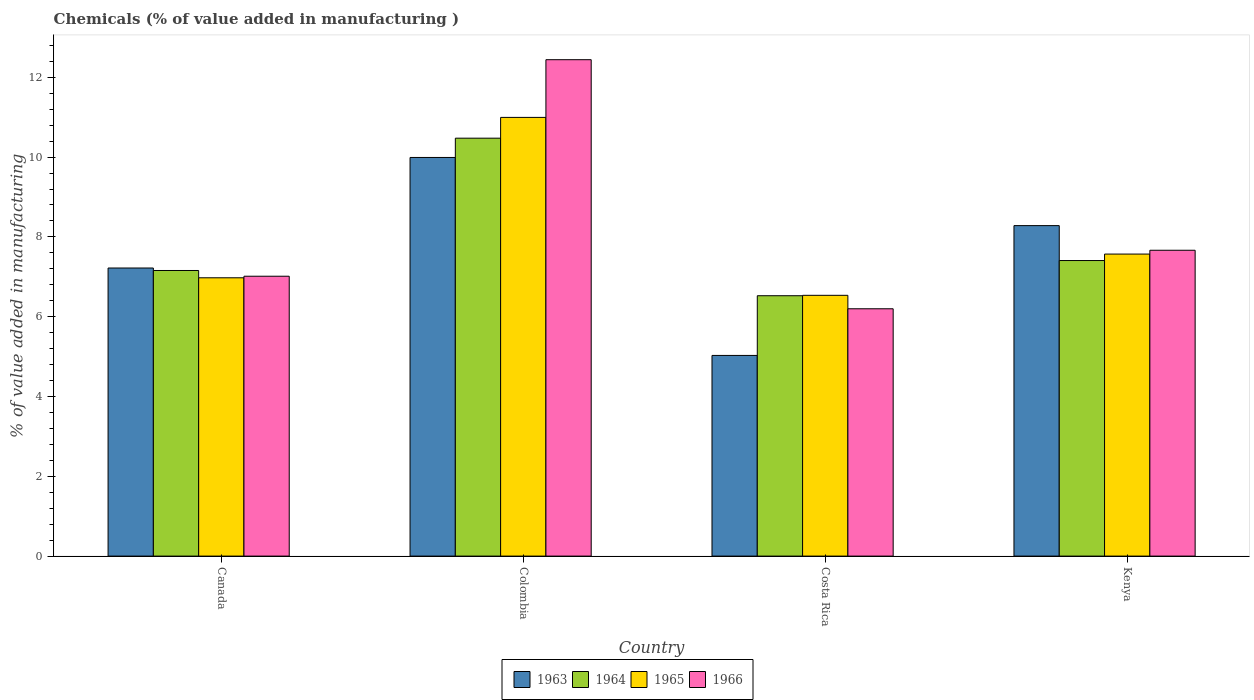How many different coloured bars are there?
Keep it short and to the point. 4. Are the number of bars per tick equal to the number of legend labels?
Offer a terse response. Yes. How many bars are there on the 1st tick from the right?
Your response must be concise. 4. In how many cases, is the number of bars for a given country not equal to the number of legend labels?
Provide a succinct answer. 0. What is the value added in manufacturing chemicals in 1965 in Kenya?
Offer a very short reply. 7.57. Across all countries, what is the maximum value added in manufacturing chemicals in 1963?
Provide a short and direct response. 9.99. Across all countries, what is the minimum value added in manufacturing chemicals in 1964?
Make the answer very short. 6.53. What is the total value added in manufacturing chemicals in 1965 in the graph?
Give a very brief answer. 32.08. What is the difference between the value added in manufacturing chemicals in 1963 in Colombia and that in Kenya?
Your answer should be very brief. 1.71. What is the difference between the value added in manufacturing chemicals in 1965 in Kenya and the value added in manufacturing chemicals in 1966 in Colombia?
Ensure brevity in your answer.  -4.87. What is the average value added in manufacturing chemicals in 1965 per country?
Your response must be concise. 8.02. What is the difference between the value added in manufacturing chemicals of/in 1964 and value added in manufacturing chemicals of/in 1965 in Canada?
Offer a terse response. 0.18. What is the ratio of the value added in manufacturing chemicals in 1965 in Canada to that in Costa Rica?
Offer a very short reply. 1.07. Is the value added in manufacturing chemicals in 1963 in Colombia less than that in Kenya?
Give a very brief answer. No. What is the difference between the highest and the second highest value added in manufacturing chemicals in 1964?
Your response must be concise. 3.32. What is the difference between the highest and the lowest value added in manufacturing chemicals in 1963?
Offer a very short reply. 4.96. Is the sum of the value added in manufacturing chemicals in 1966 in Canada and Kenya greater than the maximum value added in manufacturing chemicals in 1963 across all countries?
Keep it short and to the point. Yes. What does the 3rd bar from the left in Costa Rica represents?
Your answer should be compact. 1965. What does the 1st bar from the right in Colombia represents?
Your answer should be very brief. 1966. Is it the case that in every country, the sum of the value added in manufacturing chemicals in 1963 and value added in manufacturing chemicals in 1964 is greater than the value added in manufacturing chemicals in 1966?
Offer a terse response. Yes. How many countries are there in the graph?
Keep it short and to the point. 4. What is the difference between two consecutive major ticks on the Y-axis?
Give a very brief answer. 2. Does the graph contain any zero values?
Your response must be concise. No. How many legend labels are there?
Offer a terse response. 4. What is the title of the graph?
Provide a succinct answer. Chemicals (% of value added in manufacturing ). Does "1993" appear as one of the legend labels in the graph?
Your response must be concise. No. What is the label or title of the Y-axis?
Offer a terse response. % of value added in manufacturing. What is the % of value added in manufacturing of 1963 in Canada?
Give a very brief answer. 7.22. What is the % of value added in manufacturing of 1964 in Canada?
Offer a terse response. 7.16. What is the % of value added in manufacturing of 1965 in Canada?
Your answer should be very brief. 6.98. What is the % of value added in manufacturing in 1966 in Canada?
Your response must be concise. 7.01. What is the % of value added in manufacturing in 1963 in Colombia?
Offer a terse response. 9.99. What is the % of value added in manufacturing in 1964 in Colombia?
Give a very brief answer. 10.47. What is the % of value added in manufacturing in 1965 in Colombia?
Offer a terse response. 10.99. What is the % of value added in manufacturing of 1966 in Colombia?
Your answer should be compact. 12.44. What is the % of value added in manufacturing in 1963 in Costa Rica?
Your response must be concise. 5.03. What is the % of value added in manufacturing in 1964 in Costa Rica?
Provide a short and direct response. 6.53. What is the % of value added in manufacturing in 1965 in Costa Rica?
Provide a succinct answer. 6.54. What is the % of value added in manufacturing of 1966 in Costa Rica?
Offer a very short reply. 6.2. What is the % of value added in manufacturing of 1963 in Kenya?
Give a very brief answer. 8.28. What is the % of value added in manufacturing in 1964 in Kenya?
Your answer should be compact. 7.41. What is the % of value added in manufacturing of 1965 in Kenya?
Make the answer very short. 7.57. What is the % of value added in manufacturing in 1966 in Kenya?
Give a very brief answer. 7.67. Across all countries, what is the maximum % of value added in manufacturing of 1963?
Make the answer very short. 9.99. Across all countries, what is the maximum % of value added in manufacturing of 1964?
Offer a terse response. 10.47. Across all countries, what is the maximum % of value added in manufacturing of 1965?
Ensure brevity in your answer.  10.99. Across all countries, what is the maximum % of value added in manufacturing in 1966?
Provide a succinct answer. 12.44. Across all countries, what is the minimum % of value added in manufacturing of 1963?
Provide a short and direct response. 5.03. Across all countries, what is the minimum % of value added in manufacturing of 1964?
Your answer should be compact. 6.53. Across all countries, what is the minimum % of value added in manufacturing in 1965?
Offer a very short reply. 6.54. Across all countries, what is the minimum % of value added in manufacturing of 1966?
Your answer should be very brief. 6.2. What is the total % of value added in manufacturing of 1963 in the graph?
Your response must be concise. 30.52. What is the total % of value added in manufacturing of 1964 in the graph?
Give a very brief answer. 31.57. What is the total % of value added in manufacturing of 1965 in the graph?
Keep it short and to the point. 32.08. What is the total % of value added in manufacturing in 1966 in the graph?
Provide a succinct answer. 33.32. What is the difference between the % of value added in manufacturing in 1963 in Canada and that in Colombia?
Provide a short and direct response. -2.77. What is the difference between the % of value added in manufacturing of 1964 in Canada and that in Colombia?
Make the answer very short. -3.32. What is the difference between the % of value added in manufacturing in 1965 in Canada and that in Colombia?
Keep it short and to the point. -4.02. What is the difference between the % of value added in manufacturing in 1966 in Canada and that in Colombia?
Give a very brief answer. -5.43. What is the difference between the % of value added in manufacturing in 1963 in Canada and that in Costa Rica?
Keep it short and to the point. 2.19. What is the difference between the % of value added in manufacturing in 1964 in Canada and that in Costa Rica?
Your response must be concise. 0.63. What is the difference between the % of value added in manufacturing in 1965 in Canada and that in Costa Rica?
Make the answer very short. 0.44. What is the difference between the % of value added in manufacturing in 1966 in Canada and that in Costa Rica?
Your response must be concise. 0.82. What is the difference between the % of value added in manufacturing in 1963 in Canada and that in Kenya?
Give a very brief answer. -1.06. What is the difference between the % of value added in manufacturing in 1964 in Canada and that in Kenya?
Your response must be concise. -0.25. What is the difference between the % of value added in manufacturing in 1965 in Canada and that in Kenya?
Ensure brevity in your answer.  -0.59. What is the difference between the % of value added in manufacturing of 1966 in Canada and that in Kenya?
Provide a succinct answer. -0.65. What is the difference between the % of value added in manufacturing in 1963 in Colombia and that in Costa Rica?
Provide a short and direct response. 4.96. What is the difference between the % of value added in manufacturing in 1964 in Colombia and that in Costa Rica?
Make the answer very short. 3.95. What is the difference between the % of value added in manufacturing in 1965 in Colombia and that in Costa Rica?
Provide a short and direct response. 4.46. What is the difference between the % of value added in manufacturing of 1966 in Colombia and that in Costa Rica?
Offer a terse response. 6.24. What is the difference between the % of value added in manufacturing in 1963 in Colombia and that in Kenya?
Keep it short and to the point. 1.71. What is the difference between the % of value added in manufacturing in 1964 in Colombia and that in Kenya?
Give a very brief answer. 3.07. What is the difference between the % of value added in manufacturing of 1965 in Colombia and that in Kenya?
Keep it short and to the point. 3.43. What is the difference between the % of value added in manufacturing in 1966 in Colombia and that in Kenya?
Make the answer very short. 4.78. What is the difference between the % of value added in manufacturing of 1963 in Costa Rica and that in Kenya?
Make the answer very short. -3.25. What is the difference between the % of value added in manufacturing in 1964 in Costa Rica and that in Kenya?
Keep it short and to the point. -0.88. What is the difference between the % of value added in manufacturing in 1965 in Costa Rica and that in Kenya?
Make the answer very short. -1.03. What is the difference between the % of value added in manufacturing of 1966 in Costa Rica and that in Kenya?
Your answer should be very brief. -1.47. What is the difference between the % of value added in manufacturing in 1963 in Canada and the % of value added in manufacturing in 1964 in Colombia?
Your answer should be compact. -3.25. What is the difference between the % of value added in manufacturing in 1963 in Canada and the % of value added in manufacturing in 1965 in Colombia?
Your response must be concise. -3.77. What is the difference between the % of value added in manufacturing of 1963 in Canada and the % of value added in manufacturing of 1966 in Colombia?
Your answer should be very brief. -5.22. What is the difference between the % of value added in manufacturing in 1964 in Canada and the % of value added in manufacturing in 1965 in Colombia?
Provide a succinct answer. -3.84. What is the difference between the % of value added in manufacturing of 1964 in Canada and the % of value added in manufacturing of 1966 in Colombia?
Your answer should be compact. -5.28. What is the difference between the % of value added in manufacturing in 1965 in Canada and the % of value added in manufacturing in 1966 in Colombia?
Your response must be concise. -5.47. What is the difference between the % of value added in manufacturing of 1963 in Canada and the % of value added in manufacturing of 1964 in Costa Rica?
Provide a succinct answer. 0.69. What is the difference between the % of value added in manufacturing in 1963 in Canada and the % of value added in manufacturing in 1965 in Costa Rica?
Ensure brevity in your answer.  0.68. What is the difference between the % of value added in manufacturing of 1963 in Canada and the % of value added in manufacturing of 1966 in Costa Rica?
Offer a very short reply. 1.02. What is the difference between the % of value added in manufacturing in 1964 in Canada and the % of value added in manufacturing in 1965 in Costa Rica?
Ensure brevity in your answer.  0.62. What is the difference between the % of value added in manufacturing of 1964 in Canada and the % of value added in manufacturing of 1966 in Costa Rica?
Your response must be concise. 0.96. What is the difference between the % of value added in manufacturing in 1965 in Canada and the % of value added in manufacturing in 1966 in Costa Rica?
Keep it short and to the point. 0.78. What is the difference between the % of value added in manufacturing of 1963 in Canada and the % of value added in manufacturing of 1964 in Kenya?
Provide a short and direct response. -0.19. What is the difference between the % of value added in manufacturing of 1963 in Canada and the % of value added in manufacturing of 1965 in Kenya?
Give a very brief answer. -0.35. What is the difference between the % of value added in manufacturing of 1963 in Canada and the % of value added in manufacturing of 1966 in Kenya?
Your answer should be compact. -0.44. What is the difference between the % of value added in manufacturing of 1964 in Canada and the % of value added in manufacturing of 1965 in Kenya?
Keep it short and to the point. -0.41. What is the difference between the % of value added in manufacturing of 1964 in Canada and the % of value added in manufacturing of 1966 in Kenya?
Make the answer very short. -0.51. What is the difference between the % of value added in manufacturing of 1965 in Canada and the % of value added in manufacturing of 1966 in Kenya?
Keep it short and to the point. -0.69. What is the difference between the % of value added in manufacturing in 1963 in Colombia and the % of value added in manufacturing in 1964 in Costa Rica?
Your answer should be compact. 3.47. What is the difference between the % of value added in manufacturing of 1963 in Colombia and the % of value added in manufacturing of 1965 in Costa Rica?
Your answer should be compact. 3.46. What is the difference between the % of value added in manufacturing of 1963 in Colombia and the % of value added in manufacturing of 1966 in Costa Rica?
Your answer should be very brief. 3.79. What is the difference between the % of value added in manufacturing in 1964 in Colombia and the % of value added in manufacturing in 1965 in Costa Rica?
Offer a terse response. 3.94. What is the difference between the % of value added in manufacturing of 1964 in Colombia and the % of value added in manufacturing of 1966 in Costa Rica?
Make the answer very short. 4.28. What is the difference between the % of value added in manufacturing of 1965 in Colombia and the % of value added in manufacturing of 1966 in Costa Rica?
Offer a terse response. 4.8. What is the difference between the % of value added in manufacturing in 1963 in Colombia and the % of value added in manufacturing in 1964 in Kenya?
Provide a short and direct response. 2.58. What is the difference between the % of value added in manufacturing in 1963 in Colombia and the % of value added in manufacturing in 1965 in Kenya?
Your response must be concise. 2.42. What is the difference between the % of value added in manufacturing of 1963 in Colombia and the % of value added in manufacturing of 1966 in Kenya?
Offer a very short reply. 2.33. What is the difference between the % of value added in manufacturing in 1964 in Colombia and the % of value added in manufacturing in 1965 in Kenya?
Provide a short and direct response. 2.9. What is the difference between the % of value added in manufacturing of 1964 in Colombia and the % of value added in manufacturing of 1966 in Kenya?
Offer a terse response. 2.81. What is the difference between the % of value added in manufacturing in 1965 in Colombia and the % of value added in manufacturing in 1966 in Kenya?
Provide a succinct answer. 3.33. What is the difference between the % of value added in manufacturing in 1963 in Costa Rica and the % of value added in manufacturing in 1964 in Kenya?
Provide a succinct answer. -2.38. What is the difference between the % of value added in manufacturing in 1963 in Costa Rica and the % of value added in manufacturing in 1965 in Kenya?
Offer a terse response. -2.54. What is the difference between the % of value added in manufacturing in 1963 in Costa Rica and the % of value added in manufacturing in 1966 in Kenya?
Ensure brevity in your answer.  -2.64. What is the difference between the % of value added in manufacturing in 1964 in Costa Rica and the % of value added in manufacturing in 1965 in Kenya?
Ensure brevity in your answer.  -1.04. What is the difference between the % of value added in manufacturing in 1964 in Costa Rica and the % of value added in manufacturing in 1966 in Kenya?
Your answer should be very brief. -1.14. What is the difference between the % of value added in manufacturing of 1965 in Costa Rica and the % of value added in manufacturing of 1966 in Kenya?
Make the answer very short. -1.13. What is the average % of value added in manufacturing in 1963 per country?
Offer a very short reply. 7.63. What is the average % of value added in manufacturing in 1964 per country?
Your response must be concise. 7.89. What is the average % of value added in manufacturing in 1965 per country?
Provide a short and direct response. 8.02. What is the average % of value added in manufacturing in 1966 per country?
Ensure brevity in your answer.  8.33. What is the difference between the % of value added in manufacturing in 1963 and % of value added in manufacturing in 1964 in Canada?
Your response must be concise. 0.06. What is the difference between the % of value added in manufacturing in 1963 and % of value added in manufacturing in 1965 in Canada?
Keep it short and to the point. 0.25. What is the difference between the % of value added in manufacturing of 1963 and % of value added in manufacturing of 1966 in Canada?
Keep it short and to the point. 0.21. What is the difference between the % of value added in manufacturing in 1964 and % of value added in manufacturing in 1965 in Canada?
Offer a terse response. 0.18. What is the difference between the % of value added in manufacturing of 1964 and % of value added in manufacturing of 1966 in Canada?
Give a very brief answer. 0.14. What is the difference between the % of value added in manufacturing of 1965 and % of value added in manufacturing of 1966 in Canada?
Provide a short and direct response. -0.04. What is the difference between the % of value added in manufacturing in 1963 and % of value added in manufacturing in 1964 in Colombia?
Provide a short and direct response. -0.48. What is the difference between the % of value added in manufacturing in 1963 and % of value added in manufacturing in 1965 in Colombia?
Your answer should be compact. -1. What is the difference between the % of value added in manufacturing of 1963 and % of value added in manufacturing of 1966 in Colombia?
Offer a terse response. -2.45. What is the difference between the % of value added in manufacturing in 1964 and % of value added in manufacturing in 1965 in Colombia?
Provide a short and direct response. -0.52. What is the difference between the % of value added in manufacturing of 1964 and % of value added in manufacturing of 1966 in Colombia?
Make the answer very short. -1.97. What is the difference between the % of value added in manufacturing of 1965 and % of value added in manufacturing of 1966 in Colombia?
Offer a terse response. -1.45. What is the difference between the % of value added in manufacturing in 1963 and % of value added in manufacturing in 1964 in Costa Rica?
Your response must be concise. -1.5. What is the difference between the % of value added in manufacturing of 1963 and % of value added in manufacturing of 1965 in Costa Rica?
Provide a short and direct response. -1.51. What is the difference between the % of value added in manufacturing of 1963 and % of value added in manufacturing of 1966 in Costa Rica?
Your response must be concise. -1.17. What is the difference between the % of value added in manufacturing in 1964 and % of value added in manufacturing in 1965 in Costa Rica?
Offer a terse response. -0.01. What is the difference between the % of value added in manufacturing in 1964 and % of value added in manufacturing in 1966 in Costa Rica?
Make the answer very short. 0.33. What is the difference between the % of value added in manufacturing in 1965 and % of value added in manufacturing in 1966 in Costa Rica?
Your answer should be compact. 0.34. What is the difference between the % of value added in manufacturing of 1963 and % of value added in manufacturing of 1964 in Kenya?
Ensure brevity in your answer.  0.87. What is the difference between the % of value added in manufacturing in 1963 and % of value added in manufacturing in 1965 in Kenya?
Your response must be concise. 0.71. What is the difference between the % of value added in manufacturing of 1963 and % of value added in manufacturing of 1966 in Kenya?
Your answer should be compact. 0.62. What is the difference between the % of value added in manufacturing in 1964 and % of value added in manufacturing in 1965 in Kenya?
Your response must be concise. -0.16. What is the difference between the % of value added in manufacturing in 1964 and % of value added in manufacturing in 1966 in Kenya?
Offer a very short reply. -0.26. What is the difference between the % of value added in manufacturing in 1965 and % of value added in manufacturing in 1966 in Kenya?
Provide a succinct answer. -0.1. What is the ratio of the % of value added in manufacturing of 1963 in Canada to that in Colombia?
Make the answer very short. 0.72. What is the ratio of the % of value added in manufacturing of 1964 in Canada to that in Colombia?
Offer a terse response. 0.68. What is the ratio of the % of value added in manufacturing of 1965 in Canada to that in Colombia?
Your answer should be very brief. 0.63. What is the ratio of the % of value added in manufacturing in 1966 in Canada to that in Colombia?
Make the answer very short. 0.56. What is the ratio of the % of value added in manufacturing of 1963 in Canada to that in Costa Rica?
Give a very brief answer. 1.44. What is the ratio of the % of value added in manufacturing in 1964 in Canada to that in Costa Rica?
Make the answer very short. 1.1. What is the ratio of the % of value added in manufacturing of 1965 in Canada to that in Costa Rica?
Keep it short and to the point. 1.07. What is the ratio of the % of value added in manufacturing in 1966 in Canada to that in Costa Rica?
Ensure brevity in your answer.  1.13. What is the ratio of the % of value added in manufacturing in 1963 in Canada to that in Kenya?
Offer a terse response. 0.87. What is the ratio of the % of value added in manufacturing of 1964 in Canada to that in Kenya?
Give a very brief answer. 0.97. What is the ratio of the % of value added in manufacturing in 1965 in Canada to that in Kenya?
Your response must be concise. 0.92. What is the ratio of the % of value added in manufacturing of 1966 in Canada to that in Kenya?
Offer a very short reply. 0.92. What is the ratio of the % of value added in manufacturing in 1963 in Colombia to that in Costa Rica?
Provide a succinct answer. 1.99. What is the ratio of the % of value added in manufacturing of 1964 in Colombia to that in Costa Rica?
Give a very brief answer. 1.61. What is the ratio of the % of value added in manufacturing in 1965 in Colombia to that in Costa Rica?
Make the answer very short. 1.68. What is the ratio of the % of value added in manufacturing of 1966 in Colombia to that in Costa Rica?
Keep it short and to the point. 2.01. What is the ratio of the % of value added in manufacturing in 1963 in Colombia to that in Kenya?
Offer a very short reply. 1.21. What is the ratio of the % of value added in manufacturing in 1964 in Colombia to that in Kenya?
Your response must be concise. 1.41. What is the ratio of the % of value added in manufacturing of 1965 in Colombia to that in Kenya?
Ensure brevity in your answer.  1.45. What is the ratio of the % of value added in manufacturing in 1966 in Colombia to that in Kenya?
Provide a short and direct response. 1.62. What is the ratio of the % of value added in manufacturing in 1963 in Costa Rica to that in Kenya?
Offer a very short reply. 0.61. What is the ratio of the % of value added in manufacturing of 1964 in Costa Rica to that in Kenya?
Your answer should be compact. 0.88. What is the ratio of the % of value added in manufacturing of 1965 in Costa Rica to that in Kenya?
Your answer should be very brief. 0.86. What is the ratio of the % of value added in manufacturing of 1966 in Costa Rica to that in Kenya?
Offer a terse response. 0.81. What is the difference between the highest and the second highest % of value added in manufacturing in 1963?
Your answer should be very brief. 1.71. What is the difference between the highest and the second highest % of value added in manufacturing of 1964?
Ensure brevity in your answer.  3.07. What is the difference between the highest and the second highest % of value added in manufacturing of 1965?
Give a very brief answer. 3.43. What is the difference between the highest and the second highest % of value added in manufacturing in 1966?
Your response must be concise. 4.78. What is the difference between the highest and the lowest % of value added in manufacturing in 1963?
Keep it short and to the point. 4.96. What is the difference between the highest and the lowest % of value added in manufacturing in 1964?
Keep it short and to the point. 3.95. What is the difference between the highest and the lowest % of value added in manufacturing in 1965?
Offer a terse response. 4.46. What is the difference between the highest and the lowest % of value added in manufacturing in 1966?
Give a very brief answer. 6.24. 